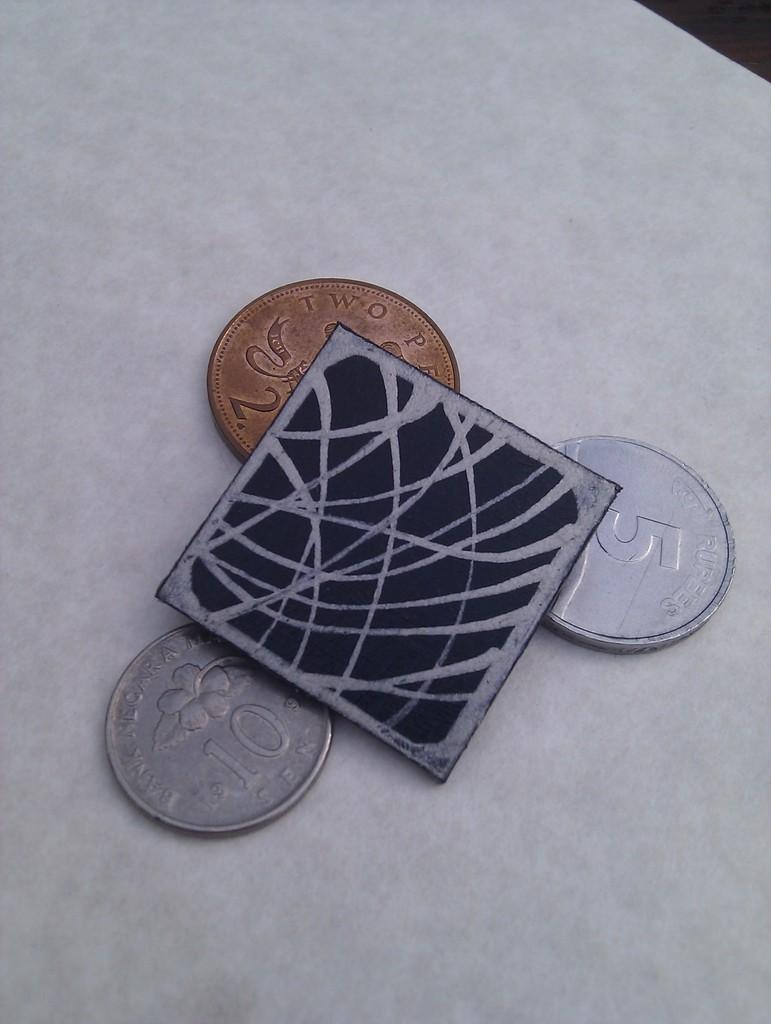<image>
Relay a brief, clear account of the picture shown. a small square on top of a gold coin and two silver coins with one of them with the number 5 on it 